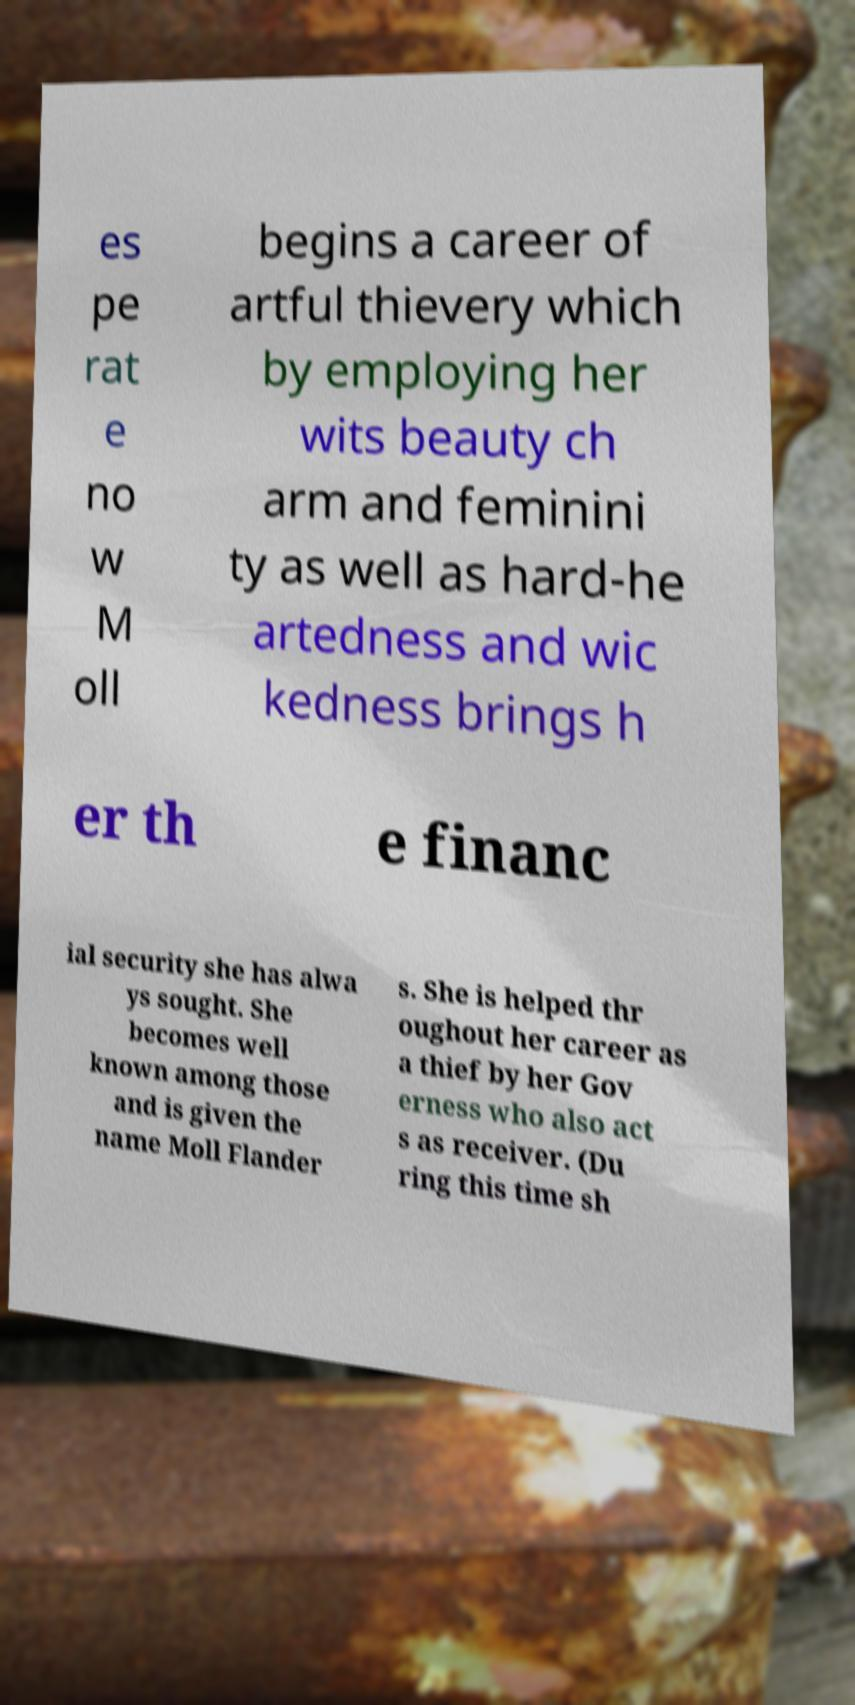I need the written content from this picture converted into text. Can you do that? es pe rat e no w M oll begins a career of artful thievery which by employing her wits beauty ch arm and feminini ty as well as hard-he artedness and wic kedness brings h er th e financ ial security she has alwa ys sought. She becomes well known among those and is given the name Moll Flander s. She is helped thr oughout her career as a thief by her Gov erness who also act s as receiver. (Du ring this time sh 